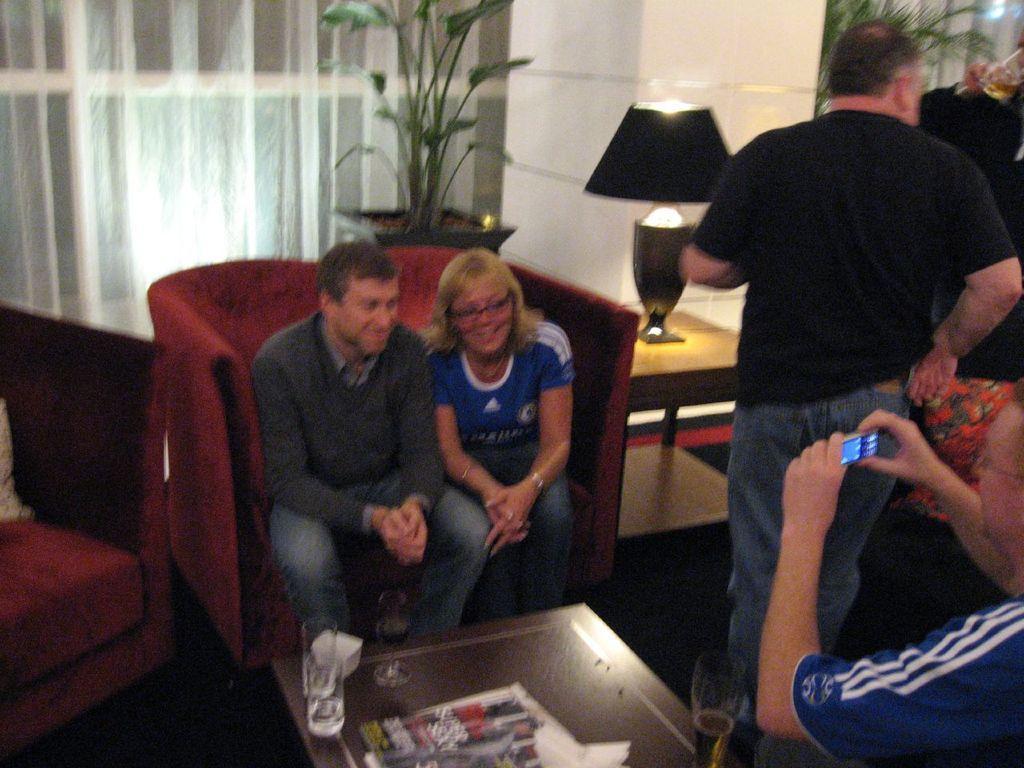Can you describe this image briefly? In this image in the middle there are two persons who are sitting on a couch and on the right side there is one person who is standing. Beside that person there is another person who is holding a mobile phone and on the top there is a window and curtain and in the middle there is a pillar, beside that piller there is one table and on that table there is one lamp and in the middle there is one flower pot and plant is there. 